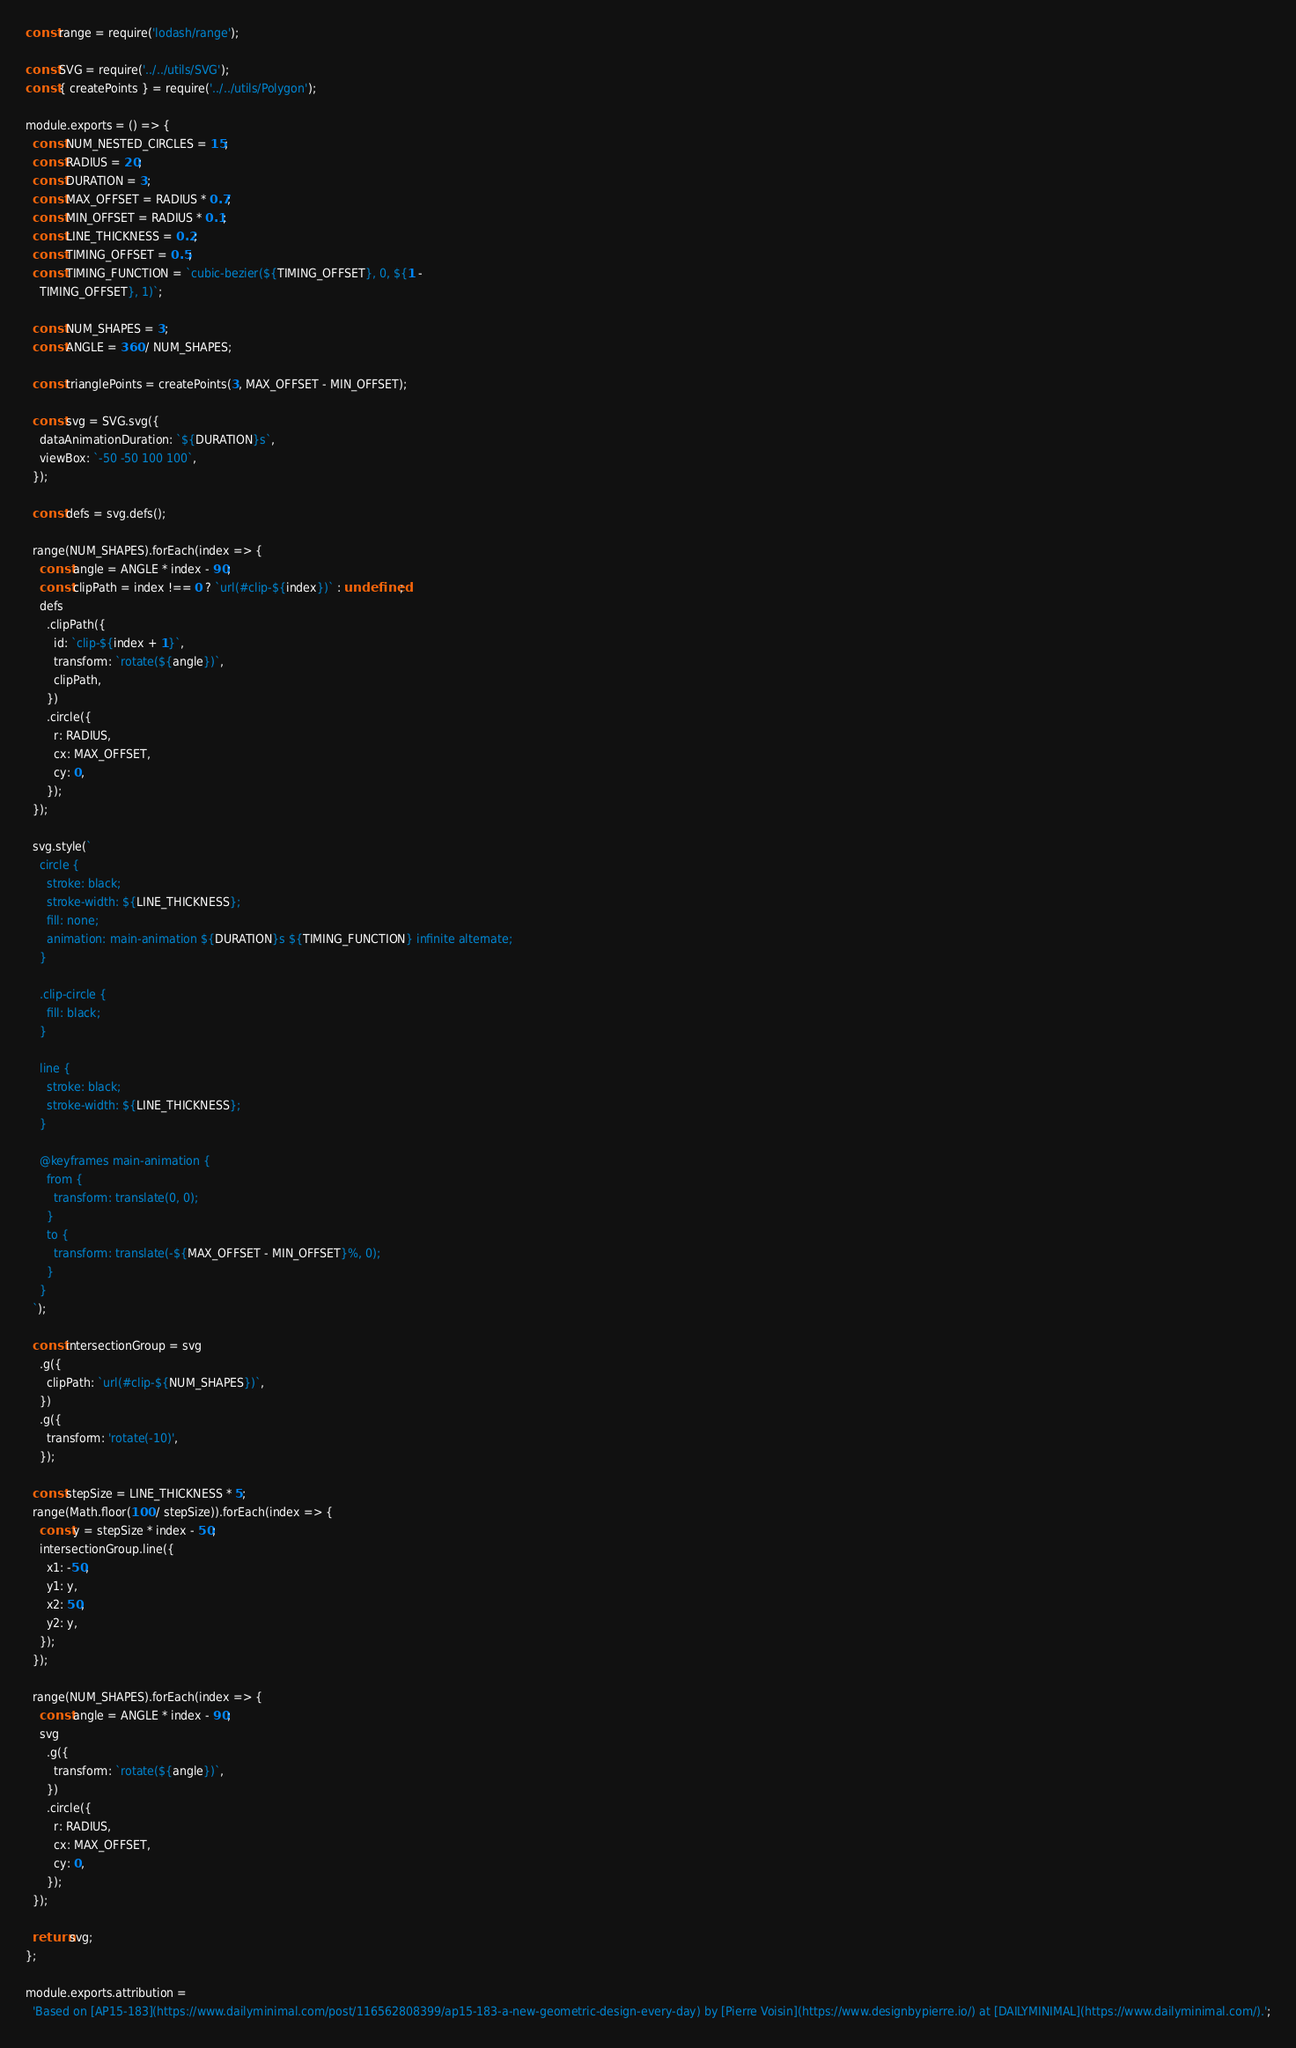Convert code to text. <code><loc_0><loc_0><loc_500><loc_500><_JavaScript_>const range = require('lodash/range');

const SVG = require('../../utils/SVG');
const { createPoints } = require('../../utils/Polygon');

module.exports = () => {
  const NUM_NESTED_CIRCLES = 15;
  const RADIUS = 20;
  const DURATION = 3;
  const MAX_OFFSET = RADIUS * 0.7;
  const MIN_OFFSET = RADIUS * 0.1;
  const LINE_THICKNESS = 0.2;
  const TIMING_OFFSET = 0.5;
  const TIMING_FUNCTION = `cubic-bezier(${TIMING_OFFSET}, 0, ${1 -
    TIMING_OFFSET}, 1)`;

  const NUM_SHAPES = 3;
  const ANGLE = 360 / NUM_SHAPES;

  const trianglePoints = createPoints(3, MAX_OFFSET - MIN_OFFSET);

  const svg = SVG.svg({
    dataAnimationDuration: `${DURATION}s`,
    viewBox: `-50 -50 100 100`,
  });

  const defs = svg.defs();

  range(NUM_SHAPES).forEach(index => {
    const angle = ANGLE * index - 90;
    const clipPath = index !== 0 ? `url(#clip-${index})` : undefined;
    defs
      .clipPath({
        id: `clip-${index + 1}`,
        transform: `rotate(${angle})`,
        clipPath,
      })
      .circle({
        r: RADIUS,
        cx: MAX_OFFSET,
        cy: 0,
      });
  });

  svg.style(`
    circle {
      stroke: black;
      stroke-width: ${LINE_THICKNESS};
      fill: none;
      animation: main-animation ${DURATION}s ${TIMING_FUNCTION} infinite alternate;
    }

    .clip-circle {
      fill: black;
    }

    line {
      stroke: black;
      stroke-width: ${LINE_THICKNESS};
    }

    @keyframes main-animation {
      from {
        transform: translate(0, 0);
      }
      to {
        transform: translate(-${MAX_OFFSET - MIN_OFFSET}%, 0);
      }
    }
  `);

  const intersectionGroup = svg
    .g({
      clipPath: `url(#clip-${NUM_SHAPES})`,
    })
    .g({
      transform: 'rotate(-10)',
    });

  const stepSize = LINE_THICKNESS * 5;
  range(Math.floor(100 / stepSize)).forEach(index => {
    const y = stepSize * index - 50;
    intersectionGroup.line({
      x1: -50,
      y1: y,
      x2: 50,
      y2: y,
    });
  });

  range(NUM_SHAPES).forEach(index => {
    const angle = ANGLE * index - 90;
    svg
      .g({
        transform: `rotate(${angle})`,
      })
      .circle({
        r: RADIUS,
        cx: MAX_OFFSET,
        cy: 0,
      });
  });

  return svg;
};

module.exports.attribution =
  'Based on [AP15-183](https://www.dailyminimal.com/post/116562808399/ap15-183-a-new-geometric-design-every-day) by [Pierre Voisin](https://www.designbypierre.io/) at [DAILYMINIMAL](https://www.dailyminimal.com/).';
</code> 